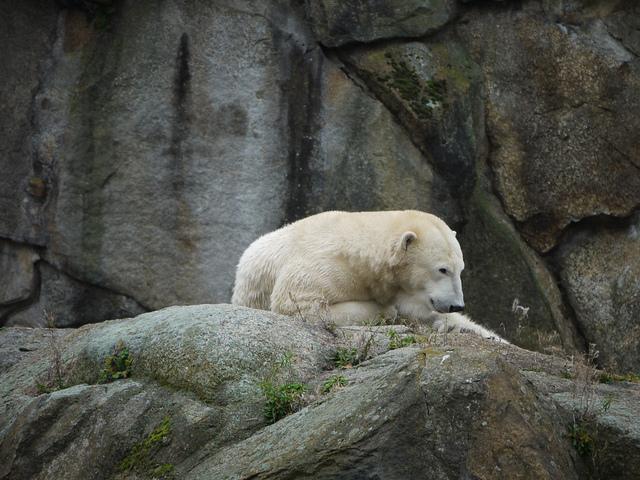What color is the bear?
Quick response, please. White. What kind of bear is pictured?
Give a very brief answer. Polar. Is the bear in the snow?
Keep it brief. No. 